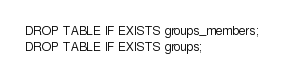<code> <loc_0><loc_0><loc_500><loc_500><_SQL_>DROP TABLE IF EXISTS groups_members;
DROP TABLE IF EXISTS groups;</code> 